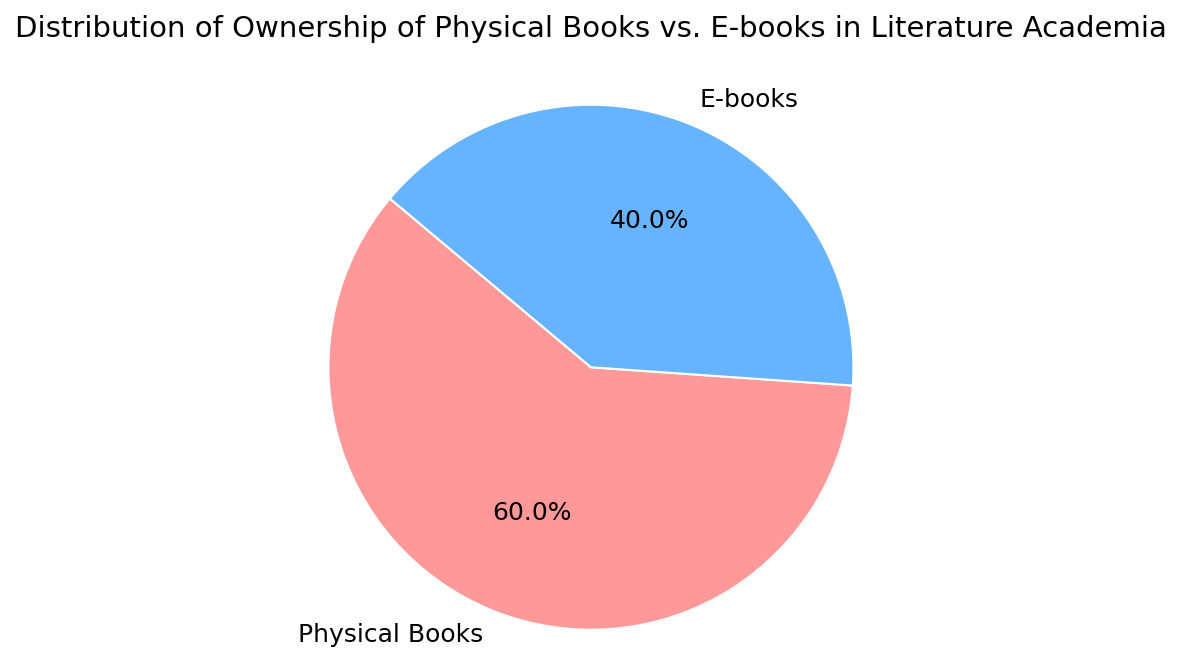what's the percentage of physical book ownership? By looking at the pie chart, we see the section labeled "Physical Books" and its associated percentage, which is 60%.
Answer: 60% how much larger is the physical book ownership percentage compared to the e-book ownership percentage? The physical book ownership percentage is 60% and the e-book ownership percentage is 40%. Subtract the e-book percentage from the physical book percentage (60% - 40% = 20%).
Answer: 20% what's the combined percentage of physical and e-book ownership? The whole pie represents 100%. The sum of physical and e-book ownerships should be 60% + 40%, which equals 100%.
Answer: 100% is the physical book ownership greater than the e-book ownership? Compare the percentages directly from the chart. Physical book ownership is 60% and e-book ownership is 40%. 60% is greater than 40%.
Answer: Yes what color represents the e-book ownership? In the pie chart, the section for e-book ownership is colored blue.
Answer: Blue if you combine 30% of physical book ownership with 20% of e-book ownership, what is their combined percentage? In the chart, physical books are 60% and e-books are 40%. Adding 30% of the physical book percentage (60 * 0.30 = 18) and 20% of the e-book percentage (40 * 0.20 = 8) gives 18 + 8 = 26%.
Answer: 26% what's the difference between the highest and lowest percentages? The highest percentage is for physical books at 60%, and the lowest is for e-books at 40%. The difference is 60% - 40% = 20%.
Answer: 20% what proportion of the pie chart is taken up by e-book ownership? The e-book ownership is 40% of the total pie chart, thus it represents 0.40 of the whole pie.
Answer: 0.40 